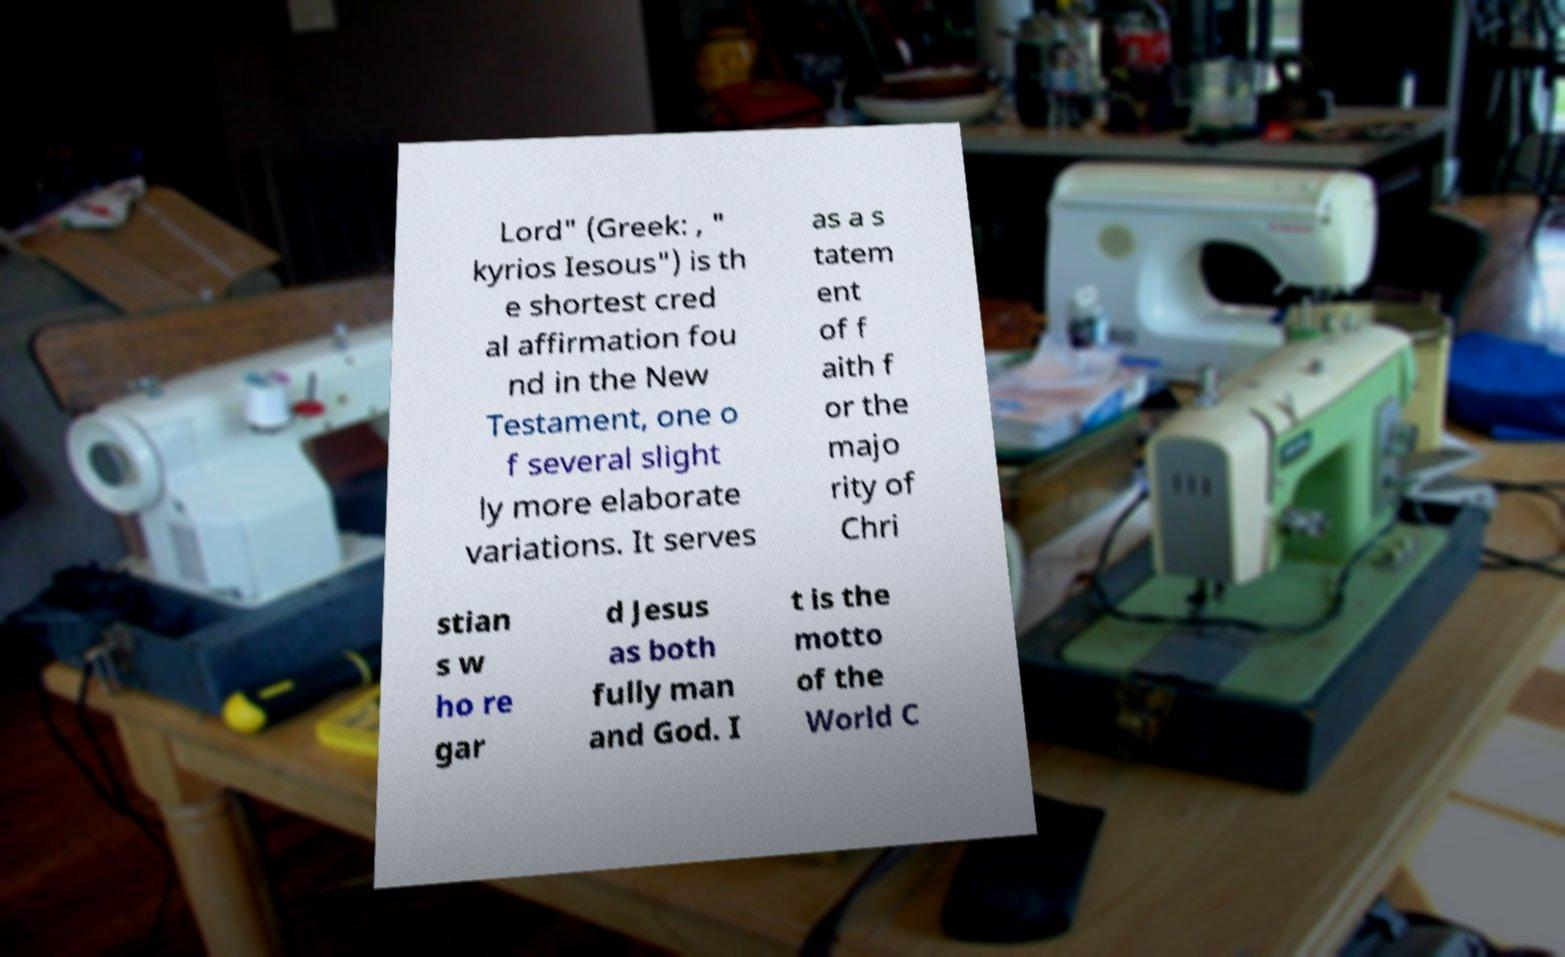For documentation purposes, I need the text within this image transcribed. Could you provide that? Lord" (Greek: , " kyrios Iesous") is th e shortest cred al affirmation fou nd in the New Testament, one o f several slight ly more elaborate variations. It serves as a s tatem ent of f aith f or the majo rity of Chri stian s w ho re gar d Jesus as both fully man and God. I t is the motto of the World C 